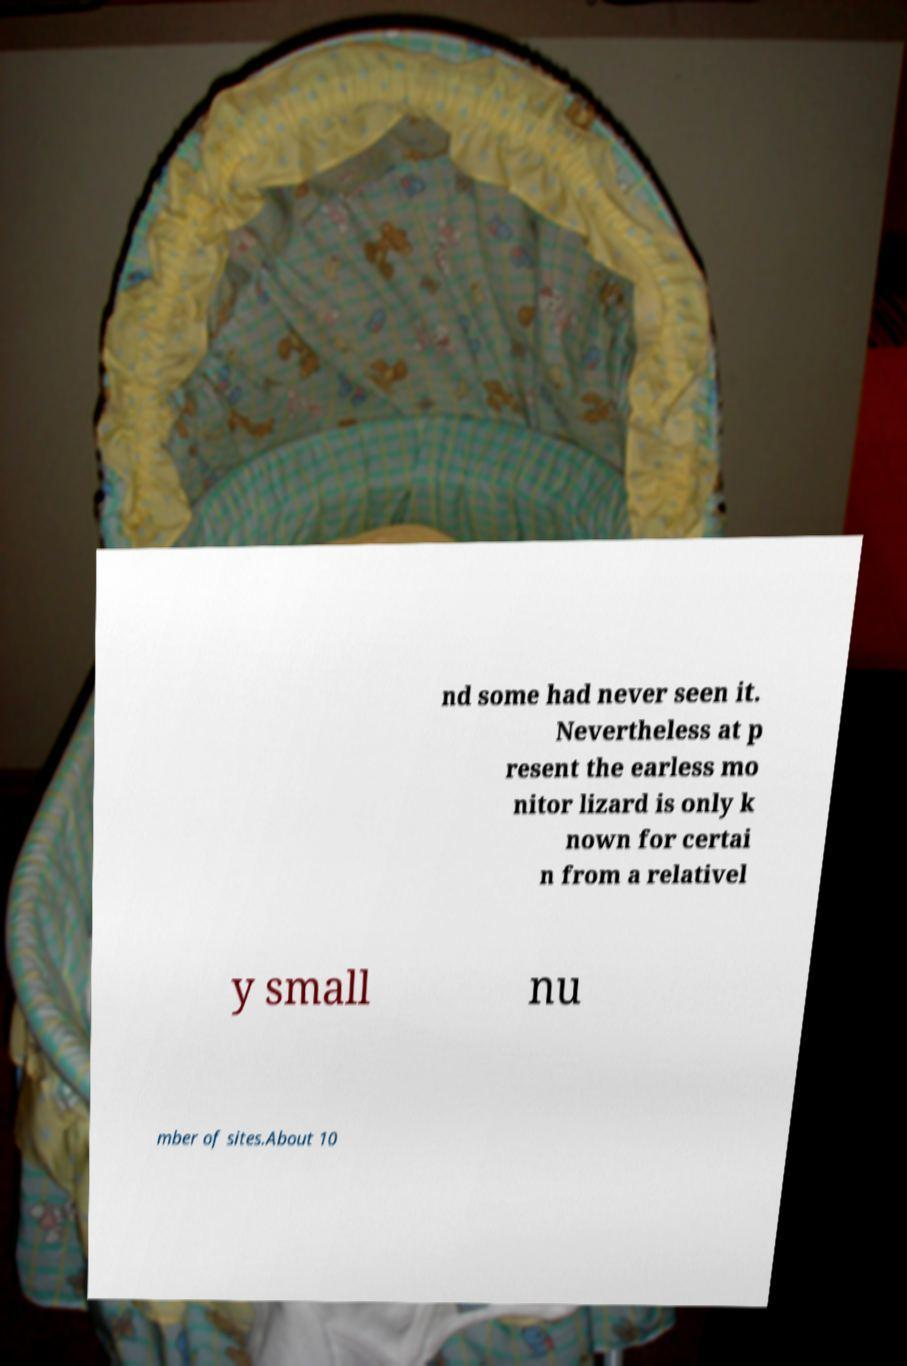Please read and relay the text visible in this image. What does it say? nd some had never seen it. Nevertheless at p resent the earless mo nitor lizard is only k nown for certai n from a relativel y small nu mber of sites.About 10 